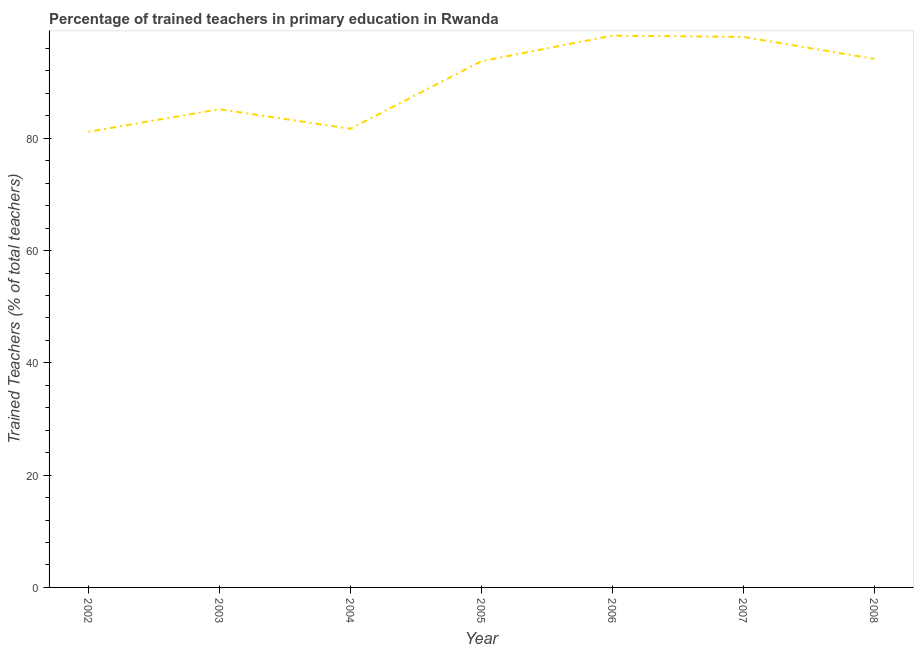What is the percentage of trained teachers in 2005?
Keep it short and to the point. 93.73. Across all years, what is the maximum percentage of trained teachers?
Give a very brief answer. 98.3. Across all years, what is the minimum percentage of trained teachers?
Provide a short and direct response. 81.17. In which year was the percentage of trained teachers maximum?
Provide a short and direct response. 2006. What is the sum of the percentage of trained teachers?
Provide a short and direct response. 632.32. What is the difference between the percentage of trained teachers in 2007 and 2008?
Your answer should be compact. 3.91. What is the average percentage of trained teachers per year?
Ensure brevity in your answer.  90.33. What is the median percentage of trained teachers?
Make the answer very short. 93.73. In how many years, is the percentage of trained teachers greater than 44 %?
Give a very brief answer. 7. What is the ratio of the percentage of trained teachers in 2004 to that in 2005?
Your answer should be compact. 0.87. Is the difference between the percentage of trained teachers in 2002 and 2003 greater than the difference between any two years?
Your response must be concise. No. What is the difference between the highest and the second highest percentage of trained teachers?
Provide a succinct answer. 0.23. Is the sum of the percentage of trained teachers in 2002 and 2004 greater than the maximum percentage of trained teachers across all years?
Offer a very short reply. Yes. What is the difference between the highest and the lowest percentage of trained teachers?
Offer a very short reply. 17.13. How many years are there in the graph?
Give a very brief answer. 7. What is the difference between two consecutive major ticks on the Y-axis?
Your answer should be very brief. 20. Are the values on the major ticks of Y-axis written in scientific E-notation?
Keep it short and to the point. No. Does the graph contain any zero values?
Make the answer very short. No. Does the graph contain grids?
Make the answer very short. No. What is the title of the graph?
Offer a terse response. Percentage of trained teachers in primary education in Rwanda. What is the label or title of the Y-axis?
Your response must be concise. Trained Teachers (% of total teachers). What is the Trained Teachers (% of total teachers) in 2002?
Your response must be concise. 81.17. What is the Trained Teachers (% of total teachers) in 2003?
Your answer should be compact. 85.18. What is the Trained Teachers (% of total teachers) of 2004?
Ensure brevity in your answer.  81.71. What is the Trained Teachers (% of total teachers) of 2005?
Provide a short and direct response. 93.73. What is the Trained Teachers (% of total teachers) of 2006?
Provide a succinct answer. 98.3. What is the Trained Teachers (% of total teachers) in 2007?
Provide a short and direct response. 98.07. What is the Trained Teachers (% of total teachers) of 2008?
Give a very brief answer. 94.16. What is the difference between the Trained Teachers (% of total teachers) in 2002 and 2003?
Make the answer very short. -4.02. What is the difference between the Trained Teachers (% of total teachers) in 2002 and 2004?
Your response must be concise. -0.54. What is the difference between the Trained Teachers (% of total teachers) in 2002 and 2005?
Your answer should be very brief. -12.56. What is the difference between the Trained Teachers (% of total teachers) in 2002 and 2006?
Ensure brevity in your answer.  -17.13. What is the difference between the Trained Teachers (% of total teachers) in 2002 and 2007?
Your answer should be very brief. -16.9. What is the difference between the Trained Teachers (% of total teachers) in 2002 and 2008?
Your answer should be compact. -12.99. What is the difference between the Trained Teachers (% of total teachers) in 2003 and 2004?
Your answer should be very brief. 3.47. What is the difference between the Trained Teachers (% of total teachers) in 2003 and 2005?
Provide a short and direct response. -8.55. What is the difference between the Trained Teachers (% of total teachers) in 2003 and 2006?
Give a very brief answer. -13.12. What is the difference between the Trained Teachers (% of total teachers) in 2003 and 2007?
Ensure brevity in your answer.  -12.89. What is the difference between the Trained Teachers (% of total teachers) in 2003 and 2008?
Keep it short and to the point. -8.98. What is the difference between the Trained Teachers (% of total teachers) in 2004 and 2005?
Offer a very short reply. -12.02. What is the difference between the Trained Teachers (% of total teachers) in 2004 and 2006?
Offer a very short reply. -16.59. What is the difference between the Trained Teachers (% of total teachers) in 2004 and 2007?
Provide a succinct answer. -16.36. What is the difference between the Trained Teachers (% of total teachers) in 2004 and 2008?
Offer a very short reply. -12.45. What is the difference between the Trained Teachers (% of total teachers) in 2005 and 2006?
Your answer should be very brief. -4.57. What is the difference between the Trained Teachers (% of total teachers) in 2005 and 2007?
Keep it short and to the point. -4.34. What is the difference between the Trained Teachers (% of total teachers) in 2005 and 2008?
Provide a succinct answer. -0.43. What is the difference between the Trained Teachers (% of total teachers) in 2006 and 2007?
Keep it short and to the point. 0.23. What is the difference between the Trained Teachers (% of total teachers) in 2006 and 2008?
Offer a very short reply. 4.14. What is the difference between the Trained Teachers (% of total teachers) in 2007 and 2008?
Your response must be concise. 3.91. What is the ratio of the Trained Teachers (% of total teachers) in 2002 to that in 2003?
Provide a succinct answer. 0.95. What is the ratio of the Trained Teachers (% of total teachers) in 2002 to that in 2005?
Offer a very short reply. 0.87. What is the ratio of the Trained Teachers (% of total teachers) in 2002 to that in 2006?
Make the answer very short. 0.83. What is the ratio of the Trained Teachers (% of total teachers) in 2002 to that in 2007?
Your answer should be very brief. 0.83. What is the ratio of the Trained Teachers (% of total teachers) in 2002 to that in 2008?
Your response must be concise. 0.86. What is the ratio of the Trained Teachers (% of total teachers) in 2003 to that in 2004?
Make the answer very short. 1.04. What is the ratio of the Trained Teachers (% of total teachers) in 2003 to that in 2005?
Provide a succinct answer. 0.91. What is the ratio of the Trained Teachers (% of total teachers) in 2003 to that in 2006?
Make the answer very short. 0.87. What is the ratio of the Trained Teachers (% of total teachers) in 2003 to that in 2007?
Give a very brief answer. 0.87. What is the ratio of the Trained Teachers (% of total teachers) in 2003 to that in 2008?
Give a very brief answer. 0.91. What is the ratio of the Trained Teachers (% of total teachers) in 2004 to that in 2005?
Offer a very short reply. 0.87. What is the ratio of the Trained Teachers (% of total teachers) in 2004 to that in 2006?
Offer a very short reply. 0.83. What is the ratio of the Trained Teachers (% of total teachers) in 2004 to that in 2007?
Your answer should be compact. 0.83. What is the ratio of the Trained Teachers (% of total teachers) in 2004 to that in 2008?
Ensure brevity in your answer.  0.87. What is the ratio of the Trained Teachers (% of total teachers) in 2005 to that in 2006?
Ensure brevity in your answer.  0.95. What is the ratio of the Trained Teachers (% of total teachers) in 2005 to that in 2007?
Provide a short and direct response. 0.96. What is the ratio of the Trained Teachers (% of total teachers) in 2006 to that in 2008?
Keep it short and to the point. 1.04. What is the ratio of the Trained Teachers (% of total teachers) in 2007 to that in 2008?
Provide a succinct answer. 1.04. 